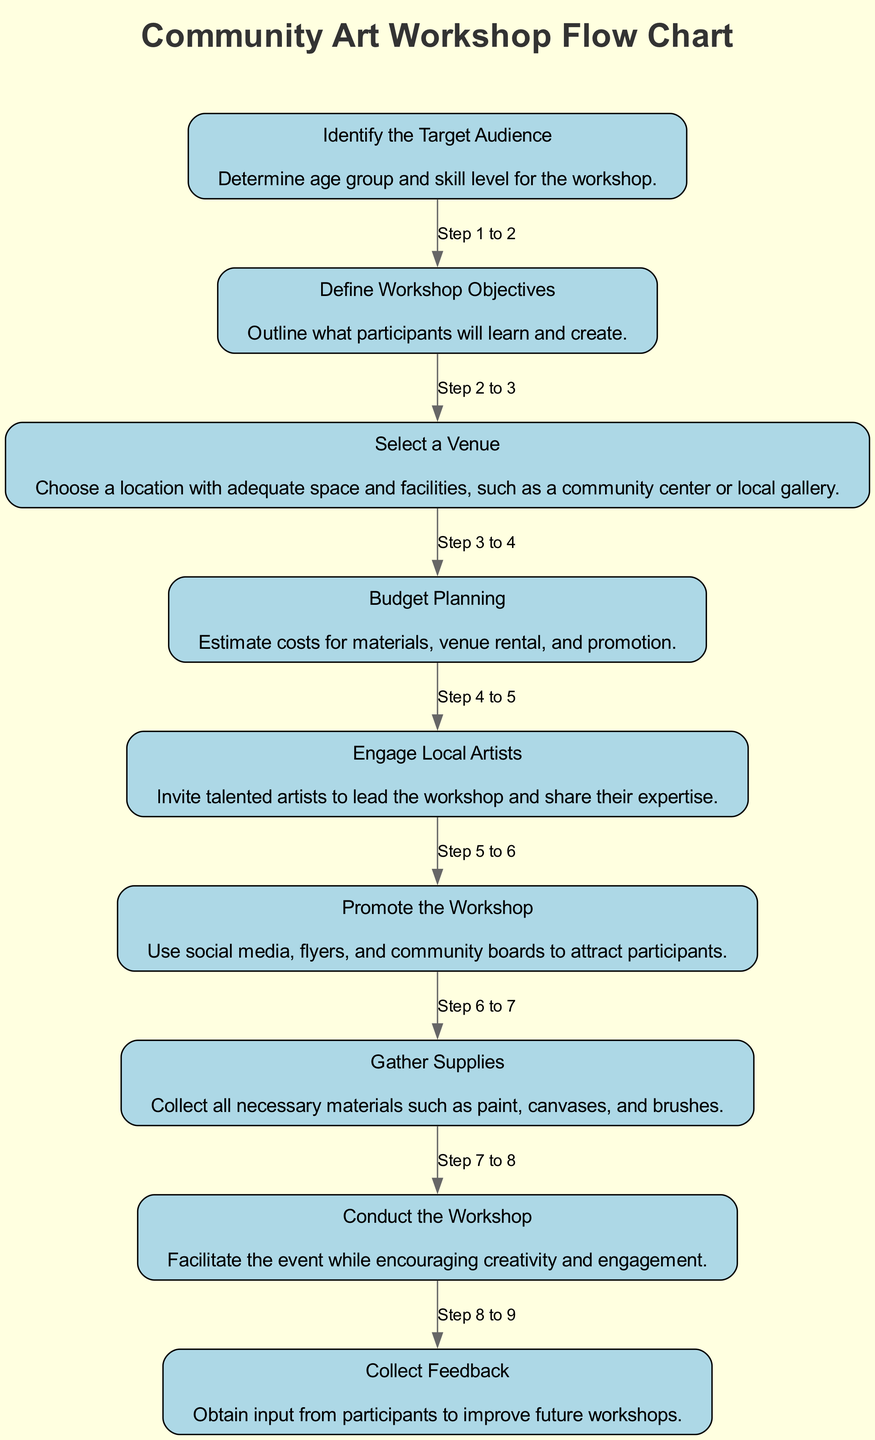What is the first step in the diagram? The first element in the flow chart is "Identify the Target Audience," which is the starting point of organizing the workshop.
Answer: Identify the Target Audience How many total steps are there in the flow chart? Counting the nodes listed in the diagram, there are a total of nine steps outlined in the process for organizing a community art workshop.
Answer: Nine What is the fifth step of the workshop organization process? The fifth step according to the diagram is "Engage Local Artists," which involves inviting artists to lead the workshop.
Answer: Engage Local Artists Which step involves promotion of the workshop? The step that focuses on promotion is "Promote the Workshop," where methods like social media and flyers are suggested.
Answer: Promote the Workshop Which two steps are directly connected? The steps "Budget Planning" and "Engage Local Artists" are sequentially linked, indicating that budget considerations come before inviting artists.
Answer: Budget Planning and Engage Local Artists What step follows after "Gather Supplies"? The step that follows "Gather Supplies" is "Conduct the Workshop," emphasizing the transition from preparation to execution of the event.
Answer: Conduct the Workshop Which node describes the objective of the workshop? The node that outlines the objective is "Define Workshop Objectives," which details the learning and creative outcomes expected from participants.
Answer: Define Workshop Objectives What type of feedback is collected after the workshop? After the workshop, "Collect Feedback" is the step where input from participants is gathered to enhance future workshops.
Answer: Collect Feedback What is the purpose of the "Select a Venue" step? The purpose of "Select a Venue" is to ensure that an appropriate location is chosen for holding the workshop, which is crucial for its success.
Answer: Choose a location 